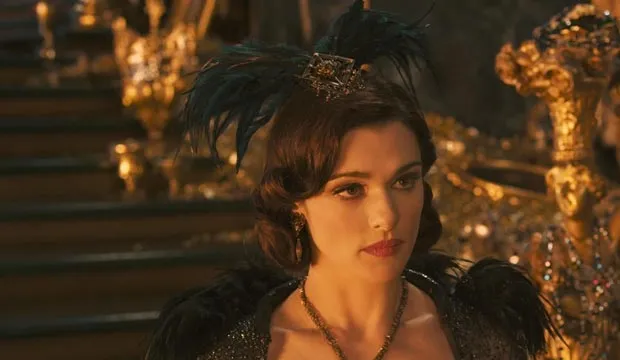How does Evanora's attire influence our perception of her character? Evanora's attire, with its rich textures and dark colors, crowned by a distinctly styled headpiece, intricately links her visual representation to themes of power and deception. The opulence of the gold details, coupled with the somber black of her gown, visually reinforces her complex role as a royal figure who harbors sinister intentions. This contrast serves to enhance her enigmatic and duplicitous nature, crucial for understanding her impact within the storyline. 